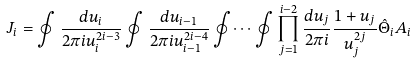Convert formula to latex. <formula><loc_0><loc_0><loc_500><loc_500>J _ { i } = \oint \frac { d u _ { i } } { 2 \pi i u _ { i } ^ { 2 i - 3 } } \oint \frac { d u _ { i - 1 } } { 2 \pi i u _ { i - 1 } ^ { 2 i - 4 } } \oint \dots \oint \prod _ { j = 1 } ^ { i - 2 } \frac { d u _ { j } } { 2 \pi i } \frac { 1 + u _ { j } } { u _ { j } ^ { 2 j } } \hat { \Theta } _ { i } A _ { i }</formula> 